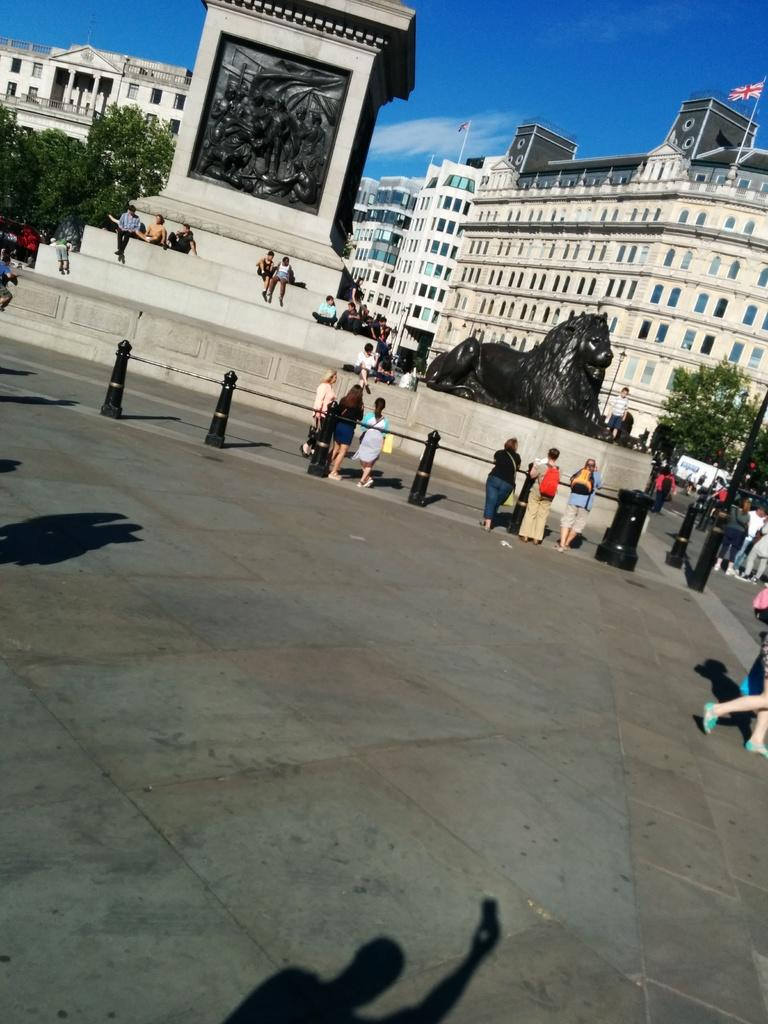What is the main subject in the foreground of the image? There is a crowd in the foreground of the image. Where is the crowd located? The crowd is on the road. What other objects ornamental or structural elements can be seen in the image? There is a fence, a lion statue, trees, poles, and buildings visible in the image. What is visible at the top of the image? The sky is visible at the top of the image. When was the image taken? The image was taken during the day. Can you see a match being lit in the image? There is no match present in the image. Is there a crown visible on the lion statue in the image? The lion statue in the image does not have a crown; it is a statue of a lion. 